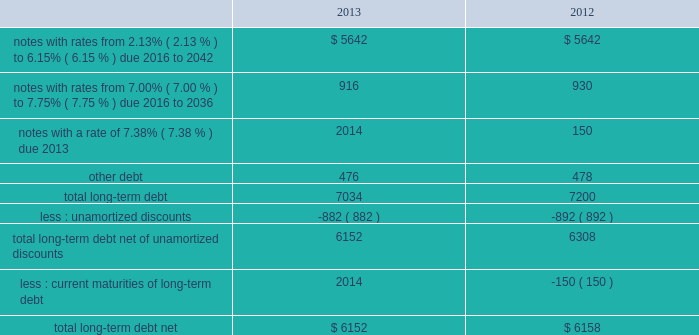As of december 31 , 2013 and 2012 , our liabilities associated with unrecognized tax benefits are not material .
We and our subsidiaries file income tax returns in the u.s .
Federal jurisdiction and various foreign jurisdictions .
With few exceptions , the statute of limitations is no longer open for u.s .
Federal or non-u.s .
Income tax examinations for the years before 2010 , other than with respect to refunds .
U.s .
Income taxes and foreign withholding taxes have not been provided on earnings of $ 222 million , $ 211 million , and $ 193 million that have not been distributed by our non-u.s .
Companies as of december 31 , 2013 , 2012 , and 2011 .
Our intention is to permanently reinvest these earnings , thereby indefinitely postponing their remittance to the u.s .
If these earnings were remitted , we estimate that the additional income taxes after foreign tax credits would have been approximately $ 50 million in 2013 , $ 45 million in 2012 , and $ 41 million in 2011 .
Our federal and foreign income tax payments , net of refunds received , were $ 787 million in 2013 , $ 890 million in 2012 , and $ 722 million in 2011 .
Our 2013 net payments reflect a $ 550 million refund from the irs primarily attributable to our tax-deductible discretionary pension contributions during the fourth quarter of 2012 ; our 2012 net payments reflect a $ 153 million refund from the irs related to a 2011 capital loss carryback claim ; and our 2011 net payments reflect a $ 250 million refund from the irs related to estimated taxes paid for 2010 .
As of december 31 , 2013 and 2012 , we had federal and foreign taxes receivable of $ 313 million and $ 662 million recorded within other current assets on our balance sheet , primarily attributable to our tax-deductible discretionary pension contributions in the fourth quarter of 2013 and 2012 and our debt exchange transaction in the fourth quarter of 2012 .
Note 9 2013 debt our long-term debt consisted of the following ( in millions ) : .
In december 2012 , we issued notes totaling $ 1.3 billion with a fixed interest rate of 4.07% ( 4.07 % ) maturing in december 2042 ( the new notes ) in exchange for outstanding notes totaling $ 1.2 billion with interest rates ranging from 5.50% ( 5.50 % ) to 8.50% ( 8.50 % ) maturing in 2023 to 2040 ( the old notes ) .
In connection with the exchange , we paid a premium of $ 393 million , of which $ 225 million was paid in cash and $ 168 million was in the form of new notes .
This premium , in addition to $ 194 million in remaining unamortized discounts related to the old notes , will be amortized as additional interest expense over the term of the new notes using the effective interest method .
We may , at our option , redeem some or all of the new notes at any time by paying the principal amount of notes being redeemed plus a make-whole premium and accrued and unpaid interest .
Interest on the new notes is payable on june 15 and december 15 of each year , beginning on june 15 , 2013 .
The new notes are unsecured senior obligations and rank equally in right of payment with all of our existing and future unsecured and unsubordinated indebtedness .
In september 2011 , we issued $ 2.0 billion of long-term notes in a registered public offering and in october 2011 , we used a portion of the proceeds to redeem all of our $ 500 million long-term notes maturing in 2013 .
In 2011 , we repurchased $ 84 million of our long-term notes through open-market purchases .
We paid premiums of $ 48 million in connection with the early extinguishments of debt , which were recognized in other non-operating income ( expense ) , net .
At december 31 , 2013 and 2012 , we had in place with a group of banks a $ 1.5 billion revolving credit facility that expires in august 2016 .
We may request and the banks may grant , at their discretion , an increase to the credit facility by an additional amount up to $ 500 million .
There were no borrowings outstanding under the credit facility through december 31 , 2013 .
Borrowings under the credit facility would be unsecured and bear interest at rates based , at our option , on a eurodollar rate or a base rate , as defined in the credit facility .
Each bank 2019s obligation to make loans under the credit facility is subject .
What was the percentage of the cash paid for the total premium associated with the exchange for new notes in 2012? 
Computations: (225 / 393)
Answer: 0.57252. 